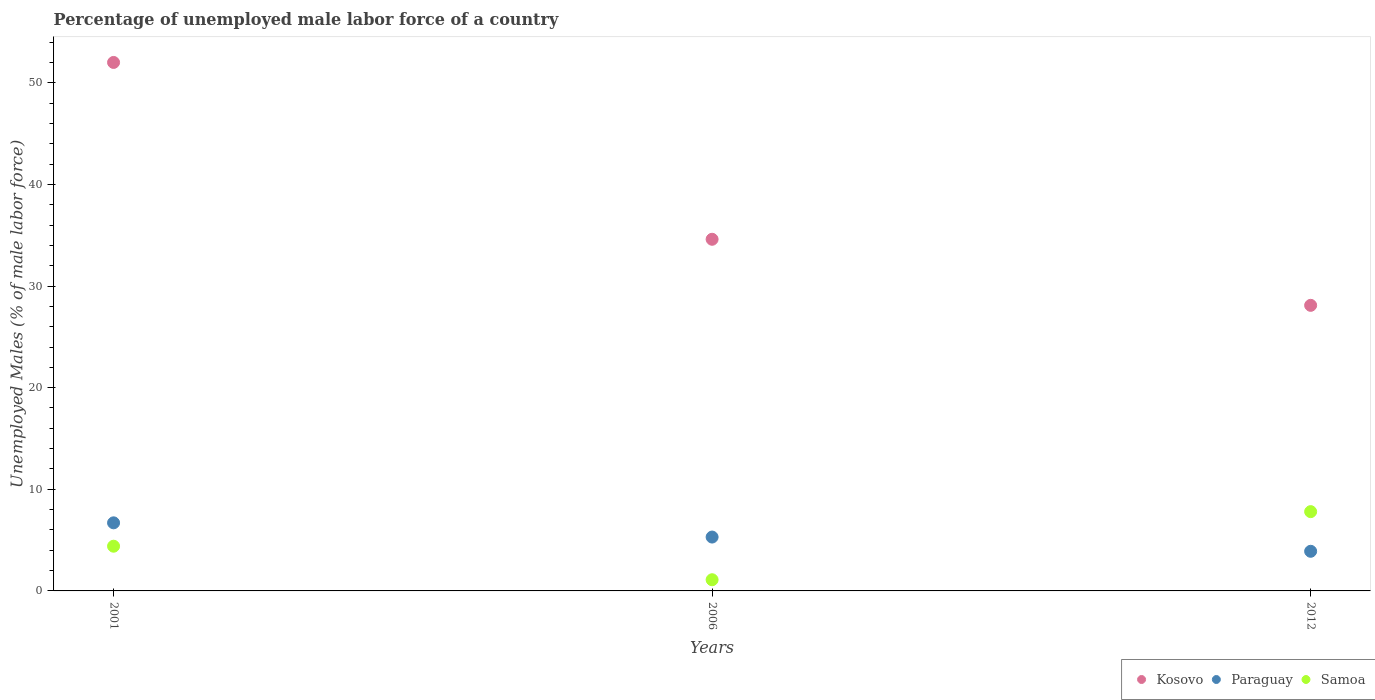Is the number of dotlines equal to the number of legend labels?
Provide a short and direct response. Yes. What is the percentage of unemployed male labor force in Paraguay in 2001?
Give a very brief answer. 6.7. Across all years, what is the maximum percentage of unemployed male labor force in Samoa?
Your answer should be very brief. 7.8. Across all years, what is the minimum percentage of unemployed male labor force in Paraguay?
Your response must be concise. 3.9. In which year was the percentage of unemployed male labor force in Kosovo maximum?
Make the answer very short. 2001. What is the total percentage of unemployed male labor force in Kosovo in the graph?
Offer a very short reply. 114.7. What is the difference between the percentage of unemployed male labor force in Samoa in 2001 and that in 2006?
Provide a short and direct response. 3.3. What is the difference between the percentage of unemployed male labor force in Samoa in 2006 and the percentage of unemployed male labor force in Kosovo in 2001?
Make the answer very short. -50.9. What is the average percentage of unemployed male labor force in Samoa per year?
Keep it short and to the point. 4.43. In the year 2001, what is the difference between the percentage of unemployed male labor force in Samoa and percentage of unemployed male labor force in Paraguay?
Give a very brief answer. -2.3. What is the ratio of the percentage of unemployed male labor force in Paraguay in 2001 to that in 2006?
Provide a succinct answer. 1.26. What is the difference between the highest and the second highest percentage of unemployed male labor force in Kosovo?
Ensure brevity in your answer.  17.4. What is the difference between the highest and the lowest percentage of unemployed male labor force in Samoa?
Provide a succinct answer. 6.7. In how many years, is the percentage of unemployed male labor force in Paraguay greater than the average percentage of unemployed male labor force in Paraguay taken over all years?
Your answer should be very brief. 2. Is the percentage of unemployed male labor force in Samoa strictly less than the percentage of unemployed male labor force in Paraguay over the years?
Offer a very short reply. No. How many dotlines are there?
Your answer should be very brief. 3. How many years are there in the graph?
Your answer should be very brief. 3. Does the graph contain grids?
Offer a terse response. No. How many legend labels are there?
Provide a succinct answer. 3. What is the title of the graph?
Make the answer very short. Percentage of unemployed male labor force of a country. Does "Gabon" appear as one of the legend labels in the graph?
Provide a succinct answer. No. What is the label or title of the Y-axis?
Make the answer very short. Unemployed Males (% of male labor force). What is the Unemployed Males (% of male labor force) of Kosovo in 2001?
Ensure brevity in your answer.  52. What is the Unemployed Males (% of male labor force) of Paraguay in 2001?
Offer a very short reply. 6.7. What is the Unemployed Males (% of male labor force) of Samoa in 2001?
Give a very brief answer. 4.4. What is the Unemployed Males (% of male labor force) in Kosovo in 2006?
Your response must be concise. 34.6. What is the Unemployed Males (% of male labor force) of Paraguay in 2006?
Provide a short and direct response. 5.3. What is the Unemployed Males (% of male labor force) of Samoa in 2006?
Offer a terse response. 1.1. What is the Unemployed Males (% of male labor force) in Kosovo in 2012?
Make the answer very short. 28.1. What is the Unemployed Males (% of male labor force) of Paraguay in 2012?
Offer a very short reply. 3.9. What is the Unemployed Males (% of male labor force) in Samoa in 2012?
Offer a terse response. 7.8. Across all years, what is the maximum Unemployed Males (% of male labor force) in Paraguay?
Give a very brief answer. 6.7. Across all years, what is the maximum Unemployed Males (% of male labor force) of Samoa?
Your answer should be compact. 7.8. Across all years, what is the minimum Unemployed Males (% of male labor force) of Kosovo?
Provide a short and direct response. 28.1. Across all years, what is the minimum Unemployed Males (% of male labor force) in Paraguay?
Keep it short and to the point. 3.9. Across all years, what is the minimum Unemployed Males (% of male labor force) in Samoa?
Your response must be concise. 1.1. What is the total Unemployed Males (% of male labor force) in Kosovo in the graph?
Provide a succinct answer. 114.7. What is the total Unemployed Males (% of male labor force) of Paraguay in the graph?
Provide a succinct answer. 15.9. What is the total Unemployed Males (% of male labor force) of Samoa in the graph?
Provide a short and direct response. 13.3. What is the difference between the Unemployed Males (% of male labor force) in Kosovo in 2001 and that in 2006?
Provide a succinct answer. 17.4. What is the difference between the Unemployed Males (% of male labor force) of Paraguay in 2001 and that in 2006?
Make the answer very short. 1.4. What is the difference between the Unemployed Males (% of male labor force) of Kosovo in 2001 and that in 2012?
Offer a terse response. 23.9. What is the difference between the Unemployed Males (% of male labor force) of Samoa in 2001 and that in 2012?
Your answer should be very brief. -3.4. What is the difference between the Unemployed Males (% of male labor force) in Paraguay in 2006 and that in 2012?
Offer a very short reply. 1.4. What is the difference between the Unemployed Males (% of male labor force) of Samoa in 2006 and that in 2012?
Ensure brevity in your answer.  -6.7. What is the difference between the Unemployed Males (% of male labor force) of Kosovo in 2001 and the Unemployed Males (% of male labor force) of Paraguay in 2006?
Your response must be concise. 46.7. What is the difference between the Unemployed Males (% of male labor force) in Kosovo in 2001 and the Unemployed Males (% of male labor force) in Samoa in 2006?
Your answer should be very brief. 50.9. What is the difference between the Unemployed Males (% of male labor force) of Paraguay in 2001 and the Unemployed Males (% of male labor force) of Samoa in 2006?
Your response must be concise. 5.6. What is the difference between the Unemployed Males (% of male labor force) of Kosovo in 2001 and the Unemployed Males (% of male labor force) of Paraguay in 2012?
Give a very brief answer. 48.1. What is the difference between the Unemployed Males (% of male labor force) of Kosovo in 2001 and the Unemployed Males (% of male labor force) of Samoa in 2012?
Give a very brief answer. 44.2. What is the difference between the Unemployed Males (% of male labor force) in Kosovo in 2006 and the Unemployed Males (% of male labor force) in Paraguay in 2012?
Ensure brevity in your answer.  30.7. What is the difference between the Unemployed Males (% of male labor force) in Kosovo in 2006 and the Unemployed Males (% of male labor force) in Samoa in 2012?
Make the answer very short. 26.8. What is the difference between the Unemployed Males (% of male labor force) in Paraguay in 2006 and the Unemployed Males (% of male labor force) in Samoa in 2012?
Ensure brevity in your answer.  -2.5. What is the average Unemployed Males (% of male labor force) in Kosovo per year?
Your answer should be very brief. 38.23. What is the average Unemployed Males (% of male labor force) of Samoa per year?
Give a very brief answer. 4.43. In the year 2001, what is the difference between the Unemployed Males (% of male labor force) of Kosovo and Unemployed Males (% of male labor force) of Paraguay?
Provide a short and direct response. 45.3. In the year 2001, what is the difference between the Unemployed Males (% of male labor force) in Kosovo and Unemployed Males (% of male labor force) in Samoa?
Your answer should be very brief. 47.6. In the year 2006, what is the difference between the Unemployed Males (% of male labor force) in Kosovo and Unemployed Males (% of male labor force) in Paraguay?
Keep it short and to the point. 29.3. In the year 2006, what is the difference between the Unemployed Males (% of male labor force) in Kosovo and Unemployed Males (% of male labor force) in Samoa?
Keep it short and to the point. 33.5. In the year 2006, what is the difference between the Unemployed Males (% of male labor force) in Paraguay and Unemployed Males (% of male labor force) in Samoa?
Ensure brevity in your answer.  4.2. In the year 2012, what is the difference between the Unemployed Males (% of male labor force) in Kosovo and Unemployed Males (% of male labor force) in Paraguay?
Keep it short and to the point. 24.2. In the year 2012, what is the difference between the Unemployed Males (% of male labor force) in Kosovo and Unemployed Males (% of male labor force) in Samoa?
Ensure brevity in your answer.  20.3. What is the ratio of the Unemployed Males (% of male labor force) in Kosovo in 2001 to that in 2006?
Your answer should be compact. 1.5. What is the ratio of the Unemployed Males (% of male labor force) of Paraguay in 2001 to that in 2006?
Your response must be concise. 1.26. What is the ratio of the Unemployed Males (% of male labor force) in Samoa in 2001 to that in 2006?
Make the answer very short. 4. What is the ratio of the Unemployed Males (% of male labor force) in Kosovo in 2001 to that in 2012?
Make the answer very short. 1.85. What is the ratio of the Unemployed Males (% of male labor force) in Paraguay in 2001 to that in 2012?
Provide a succinct answer. 1.72. What is the ratio of the Unemployed Males (% of male labor force) in Samoa in 2001 to that in 2012?
Your answer should be compact. 0.56. What is the ratio of the Unemployed Males (% of male labor force) of Kosovo in 2006 to that in 2012?
Ensure brevity in your answer.  1.23. What is the ratio of the Unemployed Males (% of male labor force) of Paraguay in 2006 to that in 2012?
Provide a short and direct response. 1.36. What is the ratio of the Unemployed Males (% of male labor force) in Samoa in 2006 to that in 2012?
Ensure brevity in your answer.  0.14. What is the difference between the highest and the second highest Unemployed Males (% of male labor force) of Kosovo?
Your answer should be compact. 17.4. What is the difference between the highest and the second highest Unemployed Males (% of male labor force) of Paraguay?
Give a very brief answer. 1.4. What is the difference between the highest and the lowest Unemployed Males (% of male labor force) in Kosovo?
Provide a succinct answer. 23.9. 